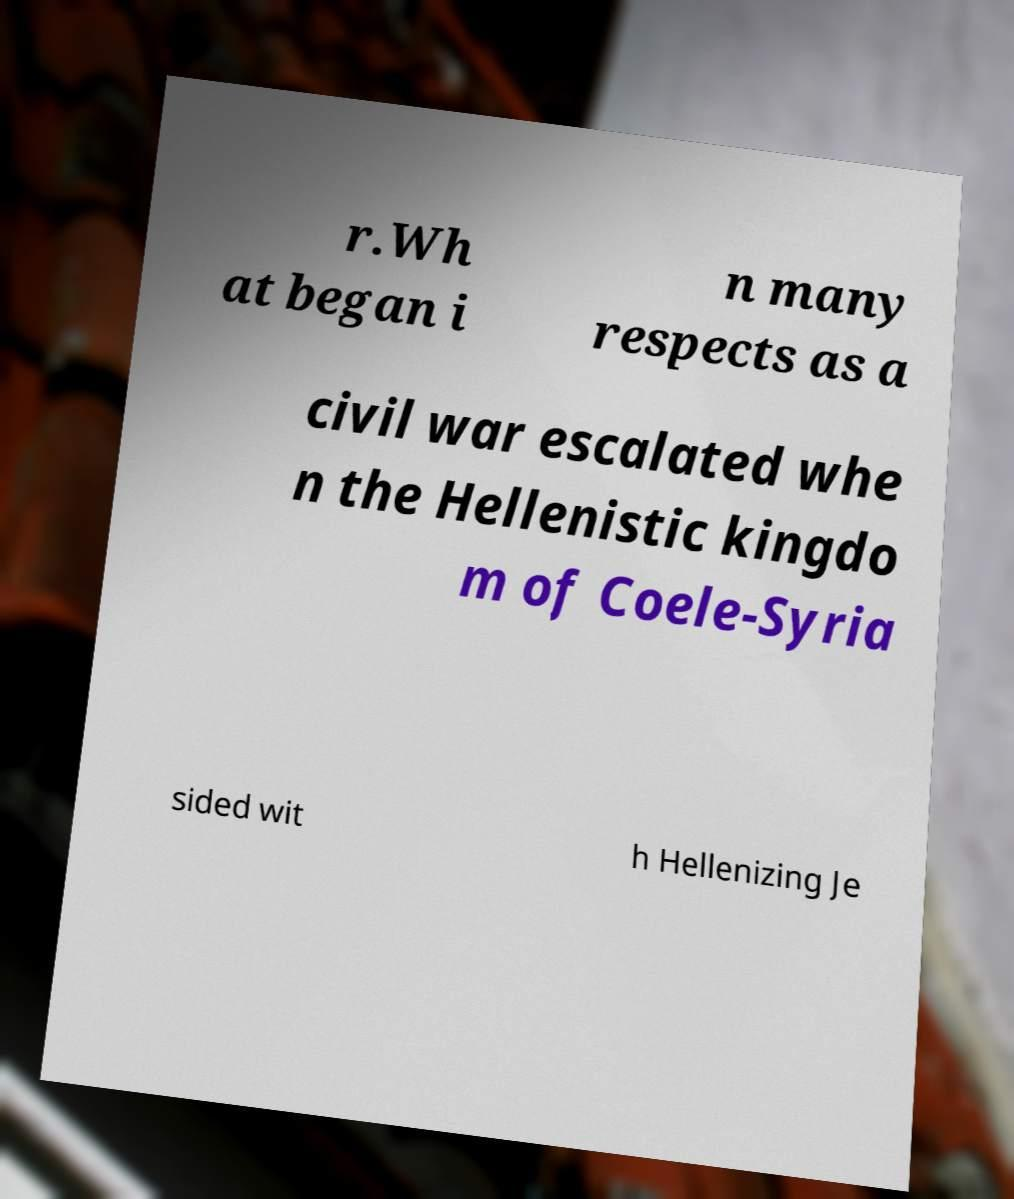For documentation purposes, I need the text within this image transcribed. Could you provide that? r.Wh at began i n many respects as a civil war escalated whe n the Hellenistic kingdo m of Coele-Syria sided wit h Hellenizing Je 